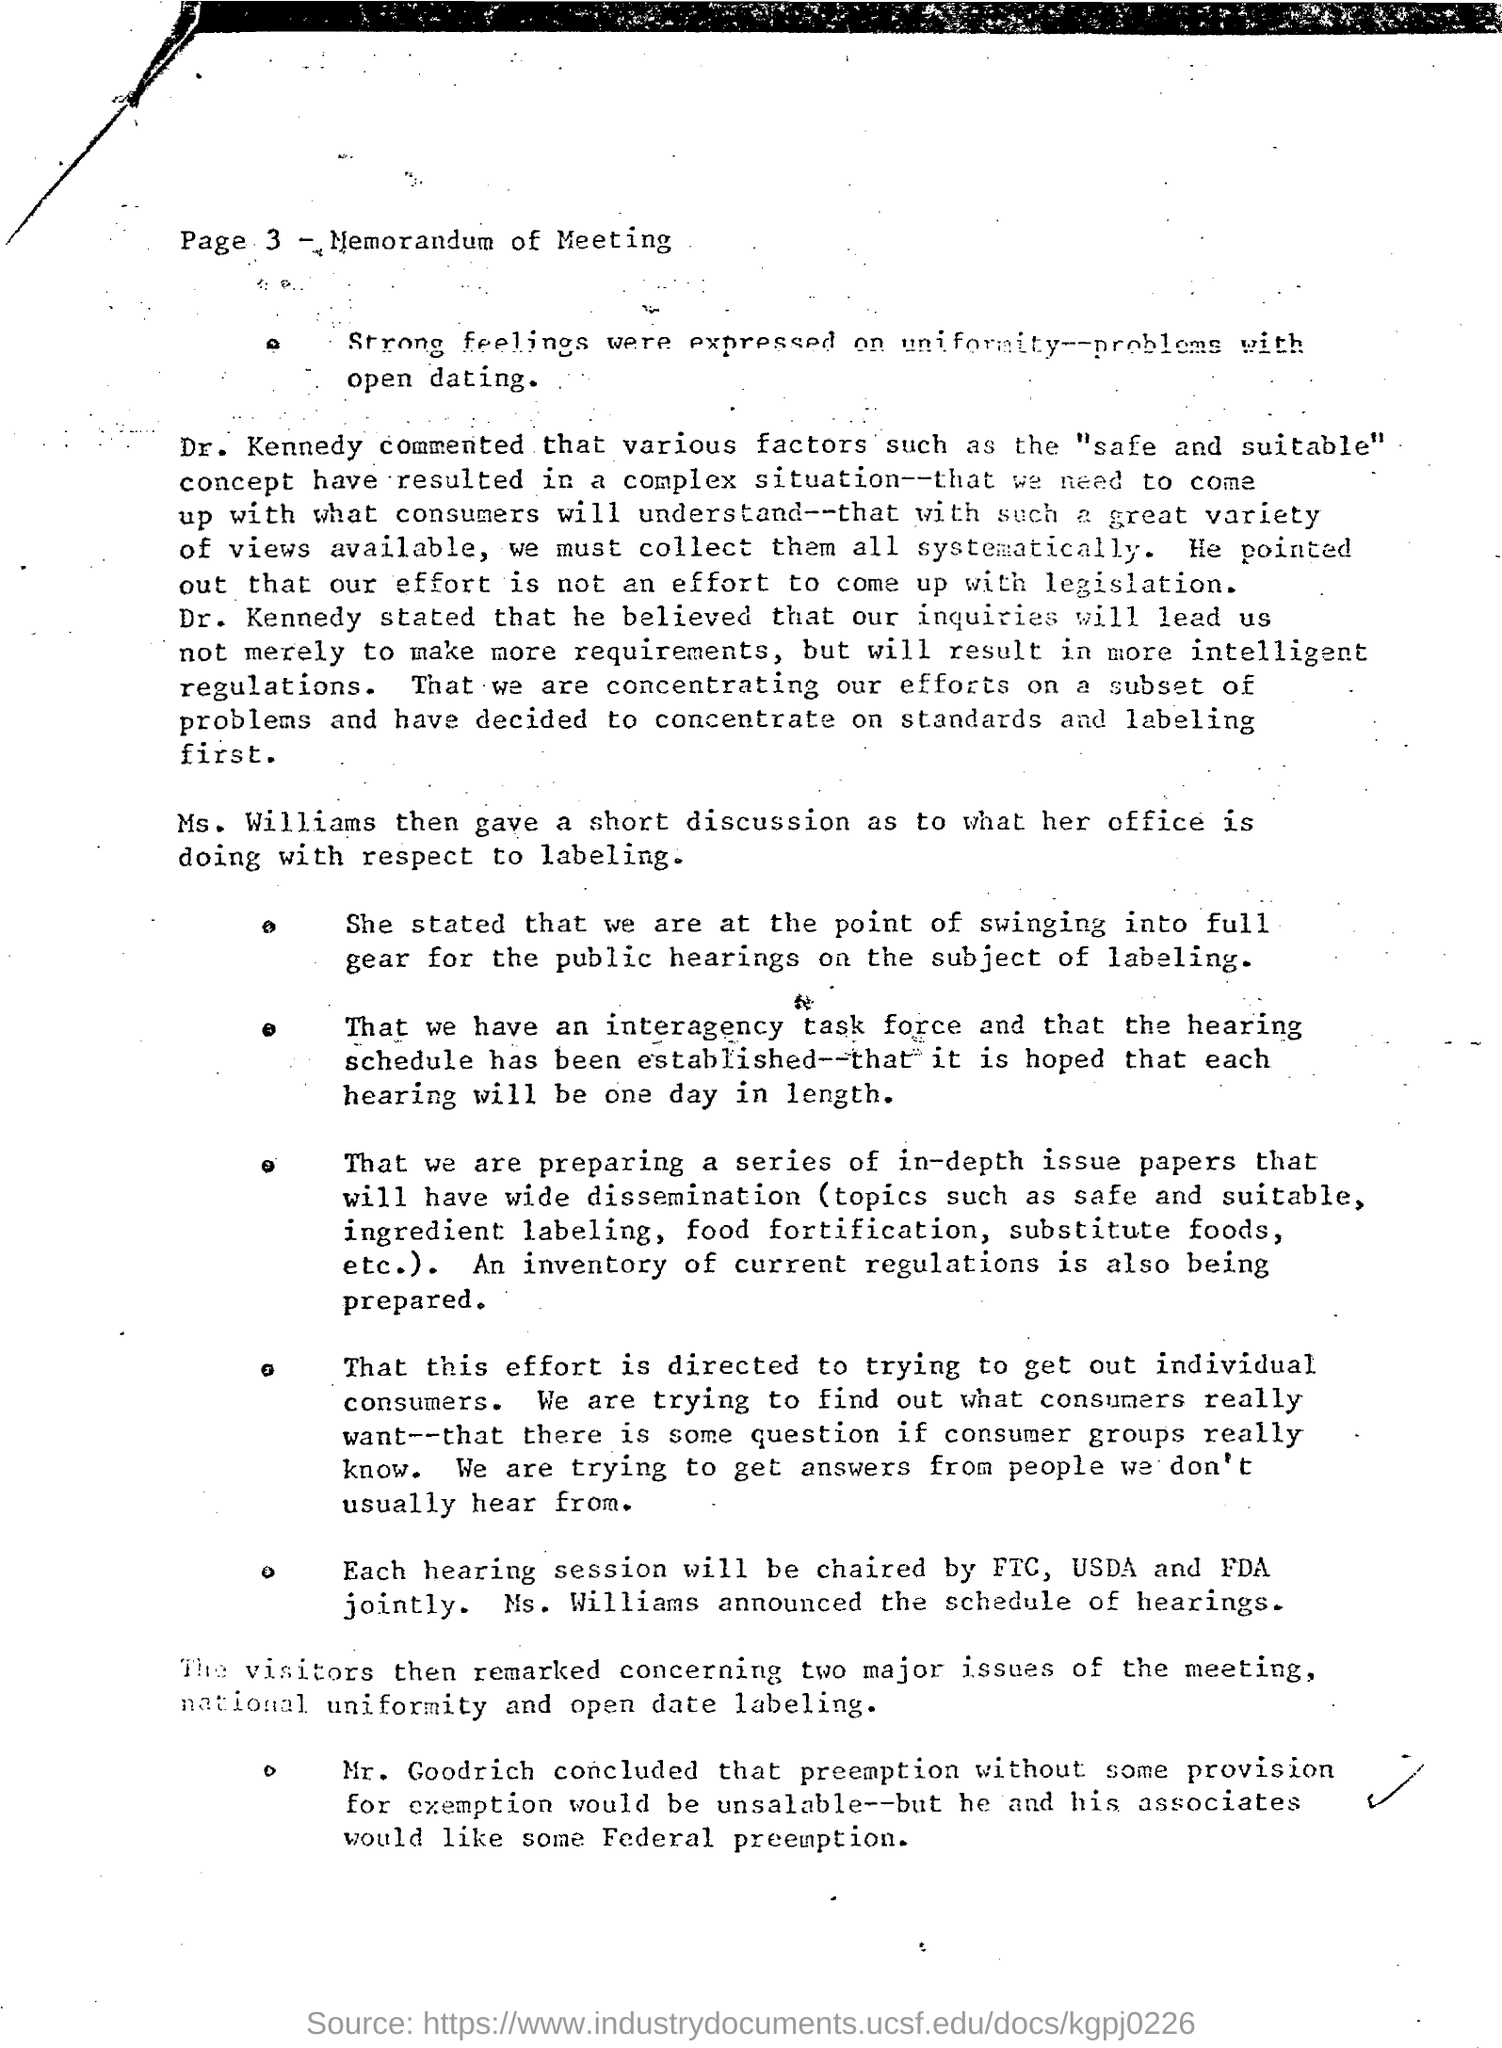Specify some key components in this picture. Ms. Williams announced the schedule of hearings. The heading of Page 3 is 'Memorandum of Meeting'. Ms. Williams gave a short discussion regarding the activities of her office regarding labeling. It is hoped that each hearing will take place over the course of one day. 